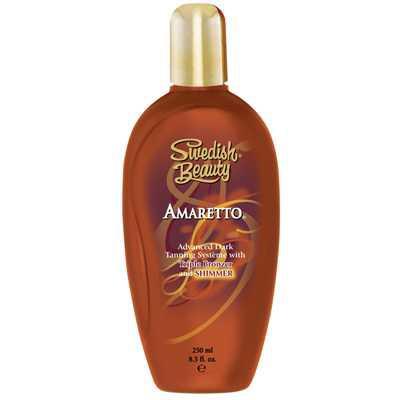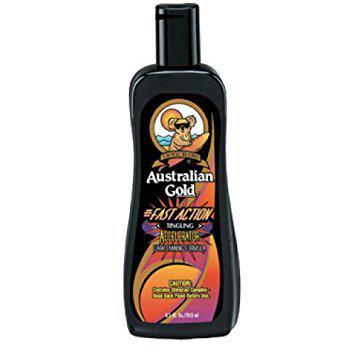The first image is the image on the left, the second image is the image on the right. Considering the images on both sides, is "One image shows a bottle standing alone, with its lid at the top, and the other image shows a bottle in front of and overlapping its upright box." valid? Answer yes or no. No. The first image is the image on the left, the second image is the image on the right. For the images shown, is this caption "At least one of the images shows the product next to the packaging." true? Answer yes or no. No. 